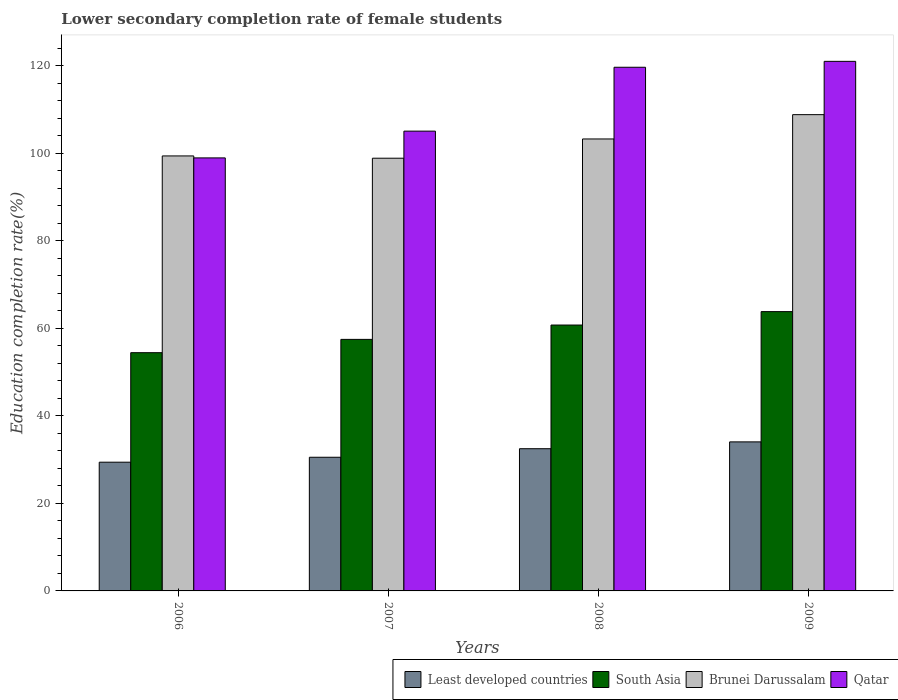How many groups of bars are there?
Provide a succinct answer. 4. Are the number of bars per tick equal to the number of legend labels?
Your answer should be very brief. Yes. Are the number of bars on each tick of the X-axis equal?
Make the answer very short. Yes. What is the label of the 4th group of bars from the left?
Your answer should be very brief. 2009. In how many cases, is the number of bars for a given year not equal to the number of legend labels?
Provide a succinct answer. 0. What is the lower secondary completion rate of female students in Least developed countries in 2006?
Provide a short and direct response. 29.41. Across all years, what is the maximum lower secondary completion rate of female students in South Asia?
Ensure brevity in your answer.  63.81. Across all years, what is the minimum lower secondary completion rate of female students in South Asia?
Keep it short and to the point. 54.42. What is the total lower secondary completion rate of female students in Least developed countries in the graph?
Keep it short and to the point. 126.47. What is the difference between the lower secondary completion rate of female students in Qatar in 2006 and that in 2009?
Ensure brevity in your answer.  -22.06. What is the difference between the lower secondary completion rate of female students in Least developed countries in 2007 and the lower secondary completion rate of female students in Qatar in 2009?
Provide a short and direct response. -90.44. What is the average lower secondary completion rate of female students in South Asia per year?
Your answer should be very brief. 59.11. In the year 2006, what is the difference between the lower secondary completion rate of female students in Brunei Darussalam and lower secondary completion rate of female students in Qatar?
Offer a terse response. 0.45. What is the ratio of the lower secondary completion rate of female students in Least developed countries in 2008 to that in 2009?
Make the answer very short. 0.95. What is the difference between the highest and the second highest lower secondary completion rate of female students in Qatar?
Provide a short and direct response. 1.35. What is the difference between the highest and the lowest lower secondary completion rate of female students in Brunei Darussalam?
Offer a terse response. 9.95. In how many years, is the lower secondary completion rate of female students in Least developed countries greater than the average lower secondary completion rate of female students in Least developed countries taken over all years?
Your answer should be very brief. 2. Is it the case that in every year, the sum of the lower secondary completion rate of female students in Qatar and lower secondary completion rate of female students in Brunei Darussalam is greater than the sum of lower secondary completion rate of female students in Least developed countries and lower secondary completion rate of female students in South Asia?
Offer a terse response. No. What does the 3rd bar from the left in 2006 represents?
Provide a succinct answer. Brunei Darussalam. What does the 3rd bar from the right in 2008 represents?
Offer a very short reply. South Asia. How many bars are there?
Offer a terse response. 16. How many years are there in the graph?
Provide a succinct answer. 4. Are the values on the major ticks of Y-axis written in scientific E-notation?
Provide a succinct answer. No. Does the graph contain grids?
Your answer should be very brief. No. How many legend labels are there?
Give a very brief answer. 4. What is the title of the graph?
Provide a succinct answer. Lower secondary completion rate of female students. What is the label or title of the Y-axis?
Provide a succinct answer. Education completion rate(%). What is the Education completion rate(%) in Least developed countries in 2006?
Your response must be concise. 29.41. What is the Education completion rate(%) in South Asia in 2006?
Your response must be concise. 54.42. What is the Education completion rate(%) in Brunei Darussalam in 2006?
Offer a terse response. 99.37. What is the Education completion rate(%) of Qatar in 2006?
Your answer should be compact. 98.92. What is the Education completion rate(%) in Least developed countries in 2007?
Provide a succinct answer. 30.53. What is the Education completion rate(%) of South Asia in 2007?
Ensure brevity in your answer.  57.46. What is the Education completion rate(%) in Brunei Darussalam in 2007?
Ensure brevity in your answer.  98.85. What is the Education completion rate(%) in Qatar in 2007?
Offer a very short reply. 105.04. What is the Education completion rate(%) of Least developed countries in 2008?
Keep it short and to the point. 32.49. What is the Education completion rate(%) of South Asia in 2008?
Your response must be concise. 60.74. What is the Education completion rate(%) in Brunei Darussalam in 2008?
Your response must be concise. 103.25. What is the Education completion rate(%) of Qatar in 2008?
Give a very brief answer. 119.63. What is the Education completion rate(%) in Least developed countries in 2009?
Provide a succinct answer. 34.05. What is the Education completion rate(%) in South Asia in 2009?
Your answer should be very brief. 63.81. What is the Education completion rate(%) of Brunei Darussalam in 2009?
Offer a very short reply. 108.8. What is the Education completion rate(%) of Qatar in 2009?
Make the answer very short. 120.98. Across all years, what is the maximum Education completion rate(%) of Least developed countries?
Provide a short and direct response. 34.05. Across all years, what is the maximum Education completion rate(%) in South Asia?
Make the answer very short. 63.81. Across all years, what is the maximum Education completion rate(%) of Brunei Darussalam?
Provide a succinct answer. 108.8. Across all years, what is the maximum Education completion rate(%) of Qatar?
Provide a short and direct response. 120.98. Across all years, what is the minimum Education completion rate(%) in Least developed countries?
Give a very brief answer. 29.41. Across all years, what is the minimum Education completion rate(%) in South Asia?
Give a very brief answer. 54.42. Across all years, what is the minimum Education completion rate(%) in Brunei Darussalam?
Give a very brief answer. 98.85. Across all years, what is the minimum Education completion rate(%) of Qatar?
Offer a very short reply. 98.92. What is the total Education completion rate(%) of Least developed countries in the graph?
Keep it short and to the point. 126.47. What is the total Education completion rate(%) in South Asia in the graph?
Your answer should be compact. 236.43. What is the total Education completion rate(%) in Brunei Darussalam in the graph?
Your answer should be compact. 410.27. What is the total Education completion rate(%) of Qatar in the graph?
Your response must be concise. 444.56. What is the difference between the Education completion rate(%) of Least developed countries in 2006 and that in 2007?
Give a very brief answer. -1.13. What is the difference between the Education completion rate(%) of South Asia in 2006 and that in 2007?
Provide a short and direct response. -3.04. What is the difference between the Education completion rate(%) in Brunei Darussalam in 2006 and that in 2007?
Your response must be concise. 0.52. What is the difference between the Education completion rate(%) in Qatar in 2006 and that in 2007?
Provide a short and direct response. -6.11. What is the difference between the Education completion rate(%) in Least developed countries in 2006 and that in 2008?
Your answer should be very brief. -3.08. What is the difference between the Education completion rate(%) of South Asia in 2006 and that in 2008?
Offer a very short reply. -6.32. What is the difference between the Education completion rate(%) of Brunei Darussalam in 2006 and that in 2008?
Offer a terse response. -3.87. What is the difference between the Education completion rate(%) of Qatar in 2006 and that in 2008?
Ensure brevity in your answer.  -20.71. What is the difference between the Education completion rate(%) in Least developed countries in 2006 and that in 2009?
Your response must be concise. -4.64. What is the difference between the Education completion rate(%) of South Asia in 2006 and that in 2009?
Ensure brevity in your answer.  -9.38. What is the difference between the Education completion rate(%) of Brunei Darussalam in 2006 and that in 2009?
Offer a terse response. -9.43. What is the difference between the Education completion rate(%) of Qatar in 2006 and that in 2009?
Give a very brief answer. -22.06. What is the difference between the Education completion rate(%) in Least developed countries in 2007 and that in 2008?
Offer a very short reply. -1.95. What is the difference between the Education completion rate(%) in South Asia in 2007 and that in 2008?
Provide a short and direct response. -3.28. What is the difference between the Education completion rate(%) of Brunei Darussalam in 2007 and that in 2008?
Make the answer very short. -4.4. What is the difference between the Education completion rate(%) of Qatar in 2007 and that in 2008?
Your answer should be compact. -14.59. What is the difference between the Education completion rate(%) of Least developed countries in 2007 and that in 2009?
Provide a short and direct response. -3.51. What is the difference between the Education completion rate(%) in South Asia in 2007 and that in 2009?
Keep it short and to the point. -6.34. What is the difference between the Education completion rate(%) in Brunei Darussalam in 2007 and that in 2009?
Your answer should be compact. -9.95. What is the difference between the Education completion rate(%) of Qatar in 2007 and that in 2009?
Your answer should be very brief. -15.94. What is the difference between the Education completion rate(%) in Least developed countries in 2008 and that in 2009?
Provide a succinct answer. -1.56. What is the difference between the Education completion rate(%) of South Asia in 2008 and that in 2009?
Ensure brevity in your answer.  -3.06. What is the difference between the Education completion rate(%) of Brunei Darussalam in 2008 and that in 2009?
Provide a succinct answer. -5.55. What is the difference between the Education completion rate(%) of Qatar in 2008 and that in 2009?
Provide a short and direct response. -1.35. What is the difference between the Education completion rate(%) of Least developed countries in 2006 and the Education completion rate(%) of South Asia in 2007?
Provide a short and direct response. -28.06. What is the difference between the Education completion rate(%) of Least developed countries in 2006 and the Education completion rate(%) of Brunei Darussalam in 2007?
Provide a short and direct response. -69.44. What is the difference between the Education completion rate(%) in Least developed countries in 2006 and the Education completion rate(%) in Qatar in 2007?
Your answer should be very brief. -75.63. What is the difference between the Education completion rate(%) in South Asia in 2006 and the Education completion rate(%) in Brunei Darussalam in 2007?
Your answer should be very brief. -44.43. What is the difference between the Education completion rate(%) of South Asia in 2006 and the Education completion rate(%) of Qatar in 2007?
Provide a succinct answer. -50.61. What is the difference between the Education completion rate(%) of Brunei Darussalam in 2006 and the Education completion rate(%) of Qatar in 2007?
Your answer should be very brief. -5.66. What is the difference between the Education completion rate(%) of Least developed countries in 2006 and the Education completion rate(%) of South Asia in 2008?
Provide a succinct answer. -31.33. What is the difference between the Education completion rate(%) in Least developed countries in 2006 and the Education completion rate(%) in Brunei Darussalam in 2008?
Provide a short and direct response. -73.84. What is the difference between the Education completion rate(%) of Least developed countries in 2006 and the Education completion rate(%) of Qatar in 2008?
Your response must be concise. -90.22. What is the difference between the Education completion rate(%) in South Asia in 2006 and the Education completion rate(%) in Brunei Darussalam in 2008?
Your answer should be compact. -48.82. What is the difference between the Education completion rate(%) of South Asia in 2006 and the Education completion rate(%) of Qatar in 2008?
Offer a very short reply. -65.2. What is the difference between the Education completion rate(%) of Brunei Darussalam in 2006 and the Education completion rate(%) of Qatar in 2008?
Provide a succinct answer. -20.25. What is the difference between the Education completion rate(%) of Least developed countries in 2006 and the Education completion rate(%) of South Asia in 2009?
Offer a very short reply. -34.4. What is the difference between the Education completion rate(%) of Least developed countries in 2006 and the Education completion rate(%) of Brunei Darussalam in 2009?
Ensure brevity in your answer.  -79.4. What is the difference between the Education completion rate(%) in Least developed countries in 2006 and the Education completion rate(%) in Qatar in 2009?
Provide a succinct answer. -91.57. What is the difference between the Education completion rate(%) of South Asia in 2006 and the Education completion rate(%) of Brunei Darussalam in 2009?
Give a very brief answer. -54.38. What is the difference between the Education completion rate(%) in South Asia in 2006 and the Education completion rate(%) in Qatar in 2009?
Keep it short and to the point. -66.55. What is the difference between the Education completion rate(%) in Brunei Darussalam in 2006 and the Education completion rate(%) in Qatar in 2009?
Make the answer very short. -21.6. What is the difference between the Education completion rate(%) in Least developed countries in 2007 and the Education completion rate(%) in South Asia in 2008?
Keep it short and to the point. -30.21. What is the difference between the Education completion rate(%) of Least developed countries in 2007 and the Education completion rate(%) of Brunei Darussalam in 2008?
Make the answer very short. -72.71. What is the difference between the Education completion rate(%) in Least developed countries in 2007 and the Education completion rate(%) in Qatar in 2008?
Offer a very short reply. -89.09. What is the difference between the Education completion rate(%) of South Asia in 2007 and the Education completion rate(%) of Brunei Darussalam in 2008?
Your response must be concise. -45.79. What is the difference between the Education completion rate(%) of South Asia in 2007 and the Education completion rate(%) of Qatar in 2008?
Provide a short and direct response. -62.17. What is the difference between the Education completion rate(%) of Brunei Darussalam in 2007 and the Education completion rate(%) of Qatar in 2008?
Your answer should be compact. -20.78. What is the difference between the Education completion rate(%) in Least developed countries in 2007 and the Education completion rate(%) in South Asia in 2009?
Give a very brief answer. -33.27. What is the difference between the Education completion rate(%) in Least developed countries in 2007 and the Education completion rate(%) in Brunei Darussalam in 2009?
Your answer should be compact. -78.27. What is the difference between the Education completion rate(%) of Least developed countries in 2007 and the Education completion rate(%) of Qatar in 2009?
Your response must be concise. -90.44. What is the difference between the Education completion rate(%) in South Asia in 2007 and the Education completion rate(%) in Brunei Darussalam in 2009?
Keep it short and to the point. -51.34. What is the difference between the Education completion rate(%) of South Asia in 2007 and the Education completion rate(%) of Qatar in 2009?
Your answer should be very brief. -63.52. What is the difference between the Education completion rate(%) in Brunei Darussalam in 2007 and the Education completion rate(%) in Qatar in 2009?
Your response must be concise. -22.13. What is the difference between the Education completion rate(%) of Least developed countries in 2008 and the Education completion rate(%) of South Asia in 2009?
Provide a short and direct response. -31.32. What is the difference between the Education completion rate(%) in Least developed countries in 2008 and the Education completion rate(%) in Brunei Darussalam in 2009?
Provide a succinct answer. -76.32. What is the difference between the Education completion rate(%) in Least developed countries in 2008 and the Education completion rate(%) in Qatar in 2009?
Provide a succinct answer. -88.49. What is the difference between the Education completion rate(%) of South Asia in 2008 and the Education completion rate(%) of Brunei Darussalam in 2009?
Provide a succinct answer. -48.06. What is the difference between the Education completion rate(%) in South Asia in 2008 and the Education completion rate(%) in Qatar in 2009?
Provide a succinct answer. -60.24. What is the difference between the Education completion rate(%) of Brunei Darussalam in 2008 and the Education completion rate(%) of Qatar in 2009?
Your answer should be very brief. -17.73. What is the average Education completion rate(%) of Least developed countries per year?
Keep it short and to the point. 31.62. What is the average Education completion rate(%) of South Asia per year?
Keep it short and to the point. 59.11. What is the average Education completion rate(%) in Brunei Darussalam per year?
Ensure brevity in your answer.  102.57. What is the average Education completion rate(%) of Qatar per year?
Offer a very short reply. 111.14. In the year 2006, what is the difference between the Education completion rate(%) in Least developed countries and Education completion rate(%) in South Asia?
Offer a terse response. -25.02. In the year 2006, what is the difference between the Education completion rate(%) in Least developed countries and Education completion rate(%) in Brunei Darussalam?
Your answer should be compact. -69.97. In the year 2006, what is the difference between the Education completion rate(%) of Least developed countries and Education completion rate(%) of Qatar?
Ensure brevity in your answer.  -69.52. In the year 2006, what is the difference between the Education completion rate(%) of South Asia and Education completion rate(%) of Brunei Darussalam?
Your answer should be compact. -44.95. In the year 2006, what is the difference between the Education completion rate(%) of South Asia and Education completion rate(%) of Qatar?
Offer a very short reply. -44.5. In the year 2006, what is the difference between the Education completion rate(%) in Brunei Darussalam and Education completion rate(%) in Qatar?
Ensure brevity in your answer.  0.45. In the year 2007, what is the difference between the Education completion rate(%) in Least developed countries and Education completion rate(%) in South Asia?
Keep it short and to the point. -26.93. In the year 2007, what is the difference between the Education completion rate(%) of Least developed countries and Education completion rate(%) of Brunei Darussalam?
Make the answer very short. -68.32. In the year 2007, what is the difference between the Education completion rate(%) of Least developed countries and Education completion rate(%) of Qatar?
Your answer should be very brief. -74.5. In the year 2007, what is the difference between the Education completion rate(%) in South Asia and Education completion rate(%) in Brunei Darussalam?
Offer a very short reply. -41.39. In the year 2007, what is the difference between the Education completion rate(%) in South Asia and Education completion rate(%) in Qatar?
Keep it short and to the point. -47.57. In the year 2007, what is the difference between the Education completion rate(%) in Brunei Darussalam and Education completion rate(%) in Qatar?
Offer a terse response. -6.19. In the year 2008, what is the difference between the Education completion rate(%) in Least developed countries and Education completion rate(%) in South Asia?
Ensure brevity in your answer.  -28.25. In the year 2008, what is the difference between the Education completion rate(%) in Least developed countries and Education completion rate(%) in Brunei Darussalam?
Your answer should be compact. -70.76. In the year 2008, what is the difference between the Education completion rate(%) in Least developed countries and Education completion rate(%) in Qatar?
Offer a terse response. -87.14. In the year 2008, what is the difference between the Education completion rate(%) in South Asia and Education completion rate(%) in Brunei Darussalam?
Offer a terse response. -42.51. In the year 2008, what is the difference between the Education completion rate(%) in South Asia and Education completion rate(%) in Qatar?
Ensure brevity in your answer.  -58.89. In the year 2008, what is the difference between the Education completion rate(%) of Brunei Darussalam and Education completion rate(%) of Qatar?
Offer a very short reply. -16.38. In the year 2009, what is the difference between the Education completion rate(%) in Least developed countries and Education completion rate(%) in South Asia?
Make the answer very short. -29.76. In the year 2009, what is the difference between the Education completion rate(%) in Least developed countries and Education completion rate(%) in Brunei Darussalam?
Your answer should be very brief. -74.75. In the year 2009, what is the difference between the Education completion rate(%) in Least developed countries and Education completion rate(%) in Qatar?
Keep it short and to the point. -86.93. In the year 2009, what is the difference between the Education completion rate(%) of South Asia and Education completion rate(%) of Brunei Darussalam?
Give a very brief answer. -45. In the year 2009, what is the difference between the Education completion rate(%) of South Asia and Education completion rate(%) of Qatar?
Your answer should be very brief. -57.17. In the year 2009, what is the difference between the Education completion rate(%) in Brunei Darussalam and Education completion rate(%) in Qatar?
Make the answer very short. -12.18. What is the ratio of the Education completion rate(%) of Least developed countries in 2006 to that in 2007?
Your answer should be compact. 0.96. What is the ratio of the Education completion rate(%) of South Asia in 2006 to that in 2007?
Make the answer very short. 0.95. What is the ratio of the Education completion rate(%) of Qatar in 2006 to that in 2007?
Provide a succinct answer. 0.94. What is the ratio of the Education completion rate(%) of Least developed countries in 2006 to that in 2008?
Ensure brevity in your answer.  0.91. What is the ratio of the Education completion rate(%) of South Asia in 2006 to that in 2008?
Provide a succinct answer. 0.9. What is the ratio of the Education completion rate(%) in Brunei Darussalam in 2006 to that in 2008?
Make the answer very short. 0.96. What is the ratio of the Education completion rate(%) of Qatar in 2006 to that in 2008?
Make the answer very short. 0.83. What is the ratio of the Education completion rate(%) of Least developed countries in 2006 to that in 2009?
Make the answer very short. 0.86. What is the ratio of the Education completion rate(%) in South Asia in 2006 to that in 2009?
Your response must be concise. 0.85. What is the ratio of the Education completion rate(%) in Brunei Darussalam in 2006 to that in 2009?
Offer a terse response. 0.91. What is the ratio of the Education completion rate(%) of Qatar in 2006 to that in 2009?
Your response must be concise. 0.82. What is the ratio of the Education completion rate(%) in Least developed countries in 2007 to that in 2008?
Your answer should be compact. 0.94. What is the ratio of the Education completion rate(%) in South Asia in 2007 to that in 2008?
Provide a short and direct response. 0.95. What is the ratio of the Education completion rate(%) in Brunei Darussalam in 2007 to that in 2008?
Offer a terse response. 0.96. What is the ratio of the Education completion rate(%) of Qatar in 2007 to that in 2008?
Offer a terse response. 0.88. What is the ratio of the Education completion rate(%) in Least developed countries in 2007 to that in 2009?
Ensure brevity in your answer.  0.9. What is the ratio of the Education completion rate(%) of South Asia in 2007 to that in 2009?
Keep it short and to the point. 0.9. What is the ratio of the Education completion rate(%) of Brunei Darussalam in 2007 to that in 2009?
Offer a very short reply. 0.91. What is the ratio of the Education completion rate(%) in Qatar in 2007 to that in 2009?
Offer a very short reply. 0.87. What is the ratio of the Education completion rate(%) of Least developed countries in 2008 to that in 2009?
Give a very brief answer. 0.95. What is the ratio of the Education completion rate(%) of Brunei Darussalam in 2008 to that in 2009?
Give a very brief answer. 0.95. What is the ratio of the Education completion rate(%) of Qatar in 2008 to that in 2009?
Your answer should be compact. 0.99. What is the difference between the highest and the second highest Education completion rate(%) of Least developed countries?
Provide a succinct answer. 1.56. What is the difference between the highest and the second highest Education completion rate(%) in South Asia?
Make the answer very short. 3.06. What is the difference between the highest and the second highest Education completion rate(%) of Brunei Darussalam?
Offer a terse response. 5.55. What is the difference between the highest and the second highest Education completion rate(%) of Qatar?
Give a very brief answer. 1.35. What is the difference between the highest and the lowest Education completion rate(%) in Least developed countries?
Provide a short and direct response. 4.64. What is the difference between the highest and the lowest Education completion rate(%) in South Asia?
Ensure brevity in your answer.  9.38. What is the difference between the highest and the lowest Education completion rate(%) of Brunei Darussalam?
Give a very brief answer. 9.95. What is the difference between the highest and the lowest Education completion rate(%) in Qatar?
Give a very brief answer. 22.06. 